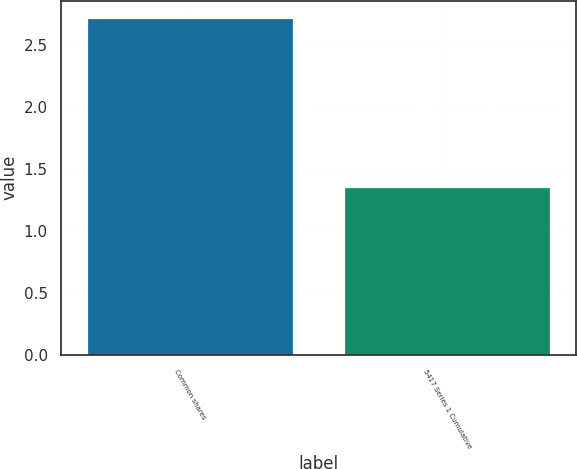Convert chart. <chart><loc_0><loc_0><loc_500><loc_500><bar_chart><fcel>Common shares<fcel>5417 Series 1 Cumulative<nl><fcel>2.72<fcel>1.35<nl></chart> 